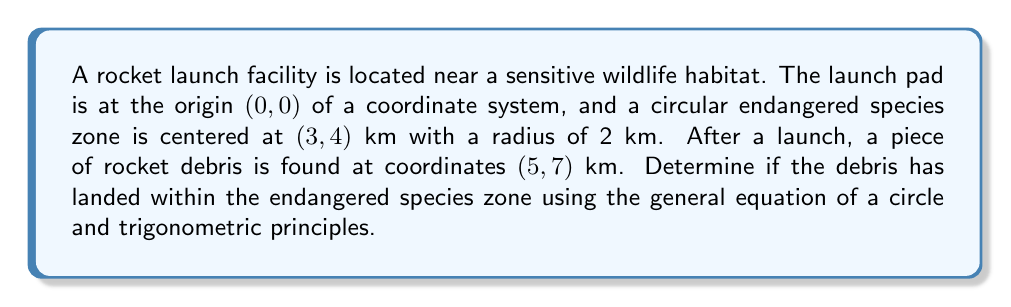Give your solution to this math problem. To solve this problem, we'll follow these steps:

1. Recall the general equation of a circle:
   $$(x - h)^2 + (y - k)^2 = r^2$$
   where (h, k) is the center and r is the radius.

2. For the endangered species zone:
   Center: (3, 4)
   Radius: 2 km
   
   The equation of this circle is:
   $$(x - 3)^2 + (y - 4)^2 = 2^2 = 4$$

3. To determine if the debris point (5, 7) is inside this circle, we need to calculate the left side of the equation and compare it to 4:

   $$(5 - 3)^2 + (7 - 4)^2 = 2^2 + 3^2 = 4 + 9 = 13$$

4. Since 13 > 4, the point (5, 7) is outside the circle.

5. To visualize this, we can use trigonometry to find the distance between the center of the circle and the debris point:

   $$d = \sqrt{(5 - 3)^2 + (7 - 4)^2} = \sqrt{2^2 + 3^2} = \sqrt{13} \approx 3.61 \text{ km}$$

   This distance is greater than the radius (2 km), confirming that the point is outside the circle.

6. We can also calculate the angle between the debris and the positive x-axis from the center of the endangered zone:

   $$\theta = \tan^{-1}\left(\frac{7 - 4}{5 - 3}\right) = \tan^{-1}\left(\frac{3}{2}\right) \approx 56.31°$$

This analysis shows that the debris landed outside the endangered species zone, but relatively close to it. The wildlife biologist should still assess the potential indirect impacts on the ecosystem.
Answer: The rocket debris at coordinates (5, 7) km has not landed within the endangered species zone. The distance from the center of the zone to the debris is approximately 3.61 km, which is greater than the zone's radius of 2 km. 